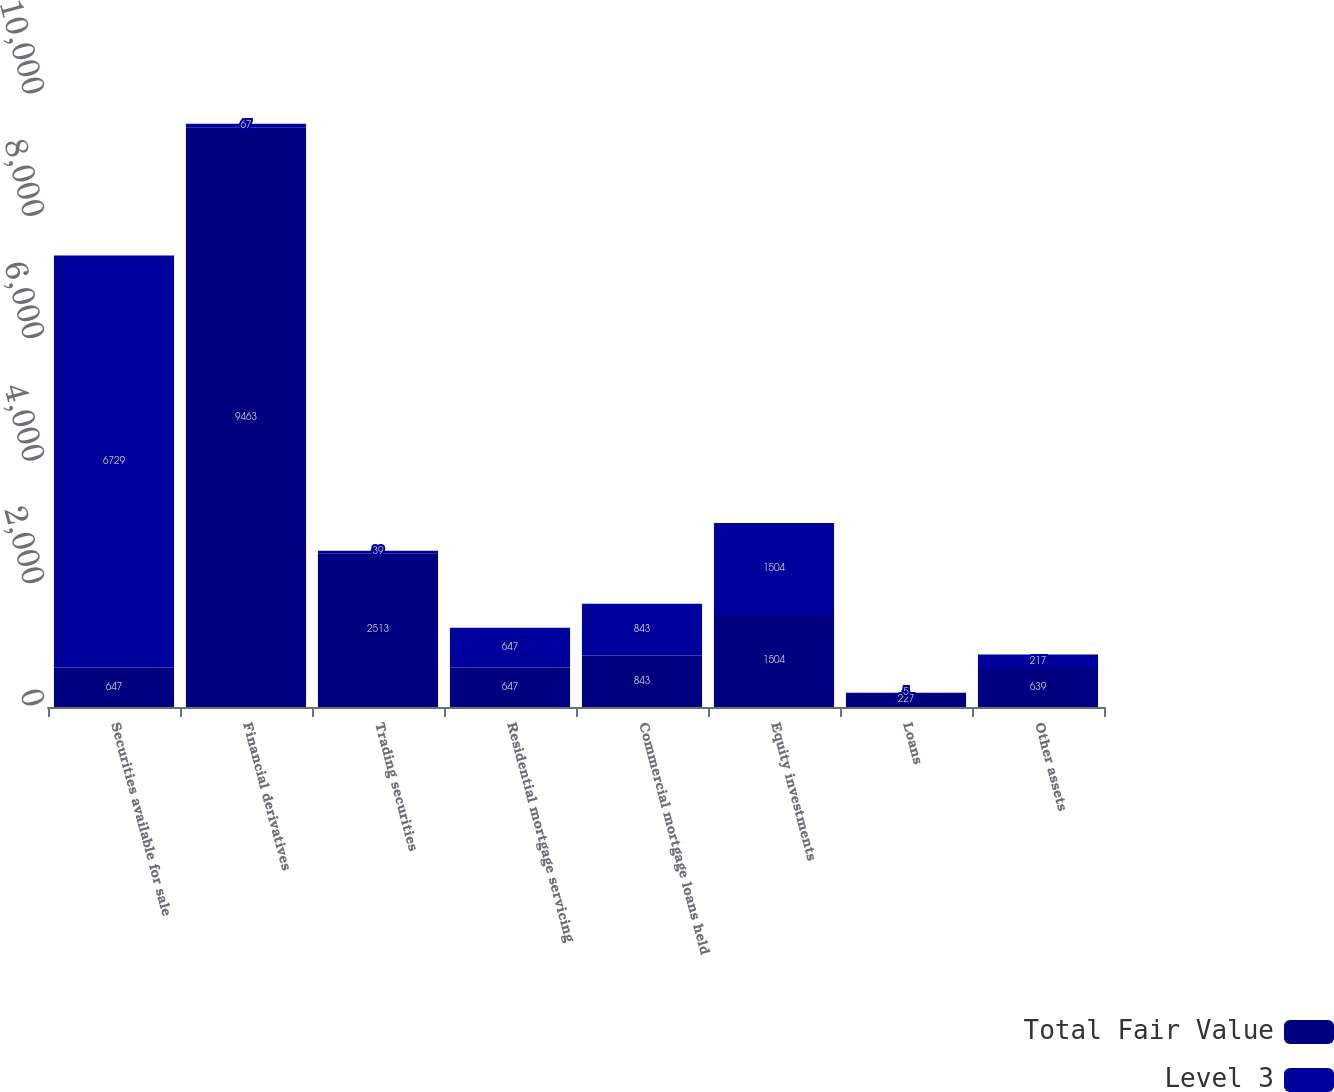Convert chart to OTSL. <chart><loc_0><loc_0><loc_500><loc_500><stacked_bar_chart><ecel><fcel>Securities available for sale<fcel>Financial derivatives<fcel>Trading securities<fcel>Residential mortgage servicing<fcel>Commercial mortgage loans held<fcel>Equity investments<fcel>Loans<fcel>Other assets<nl><fcel>Total Fair Value<fcel>647<fcel>9463<fcel>2513<fcel>647<fcel>843<fcel>1504<fcel>227<fcel>639<nl><fcel>Level 3<fcel>6729<fcel>67<fcel>39<fcel>647<fcel>843<fcel>1504<fcel>5<fcel>217<nl></chart> 